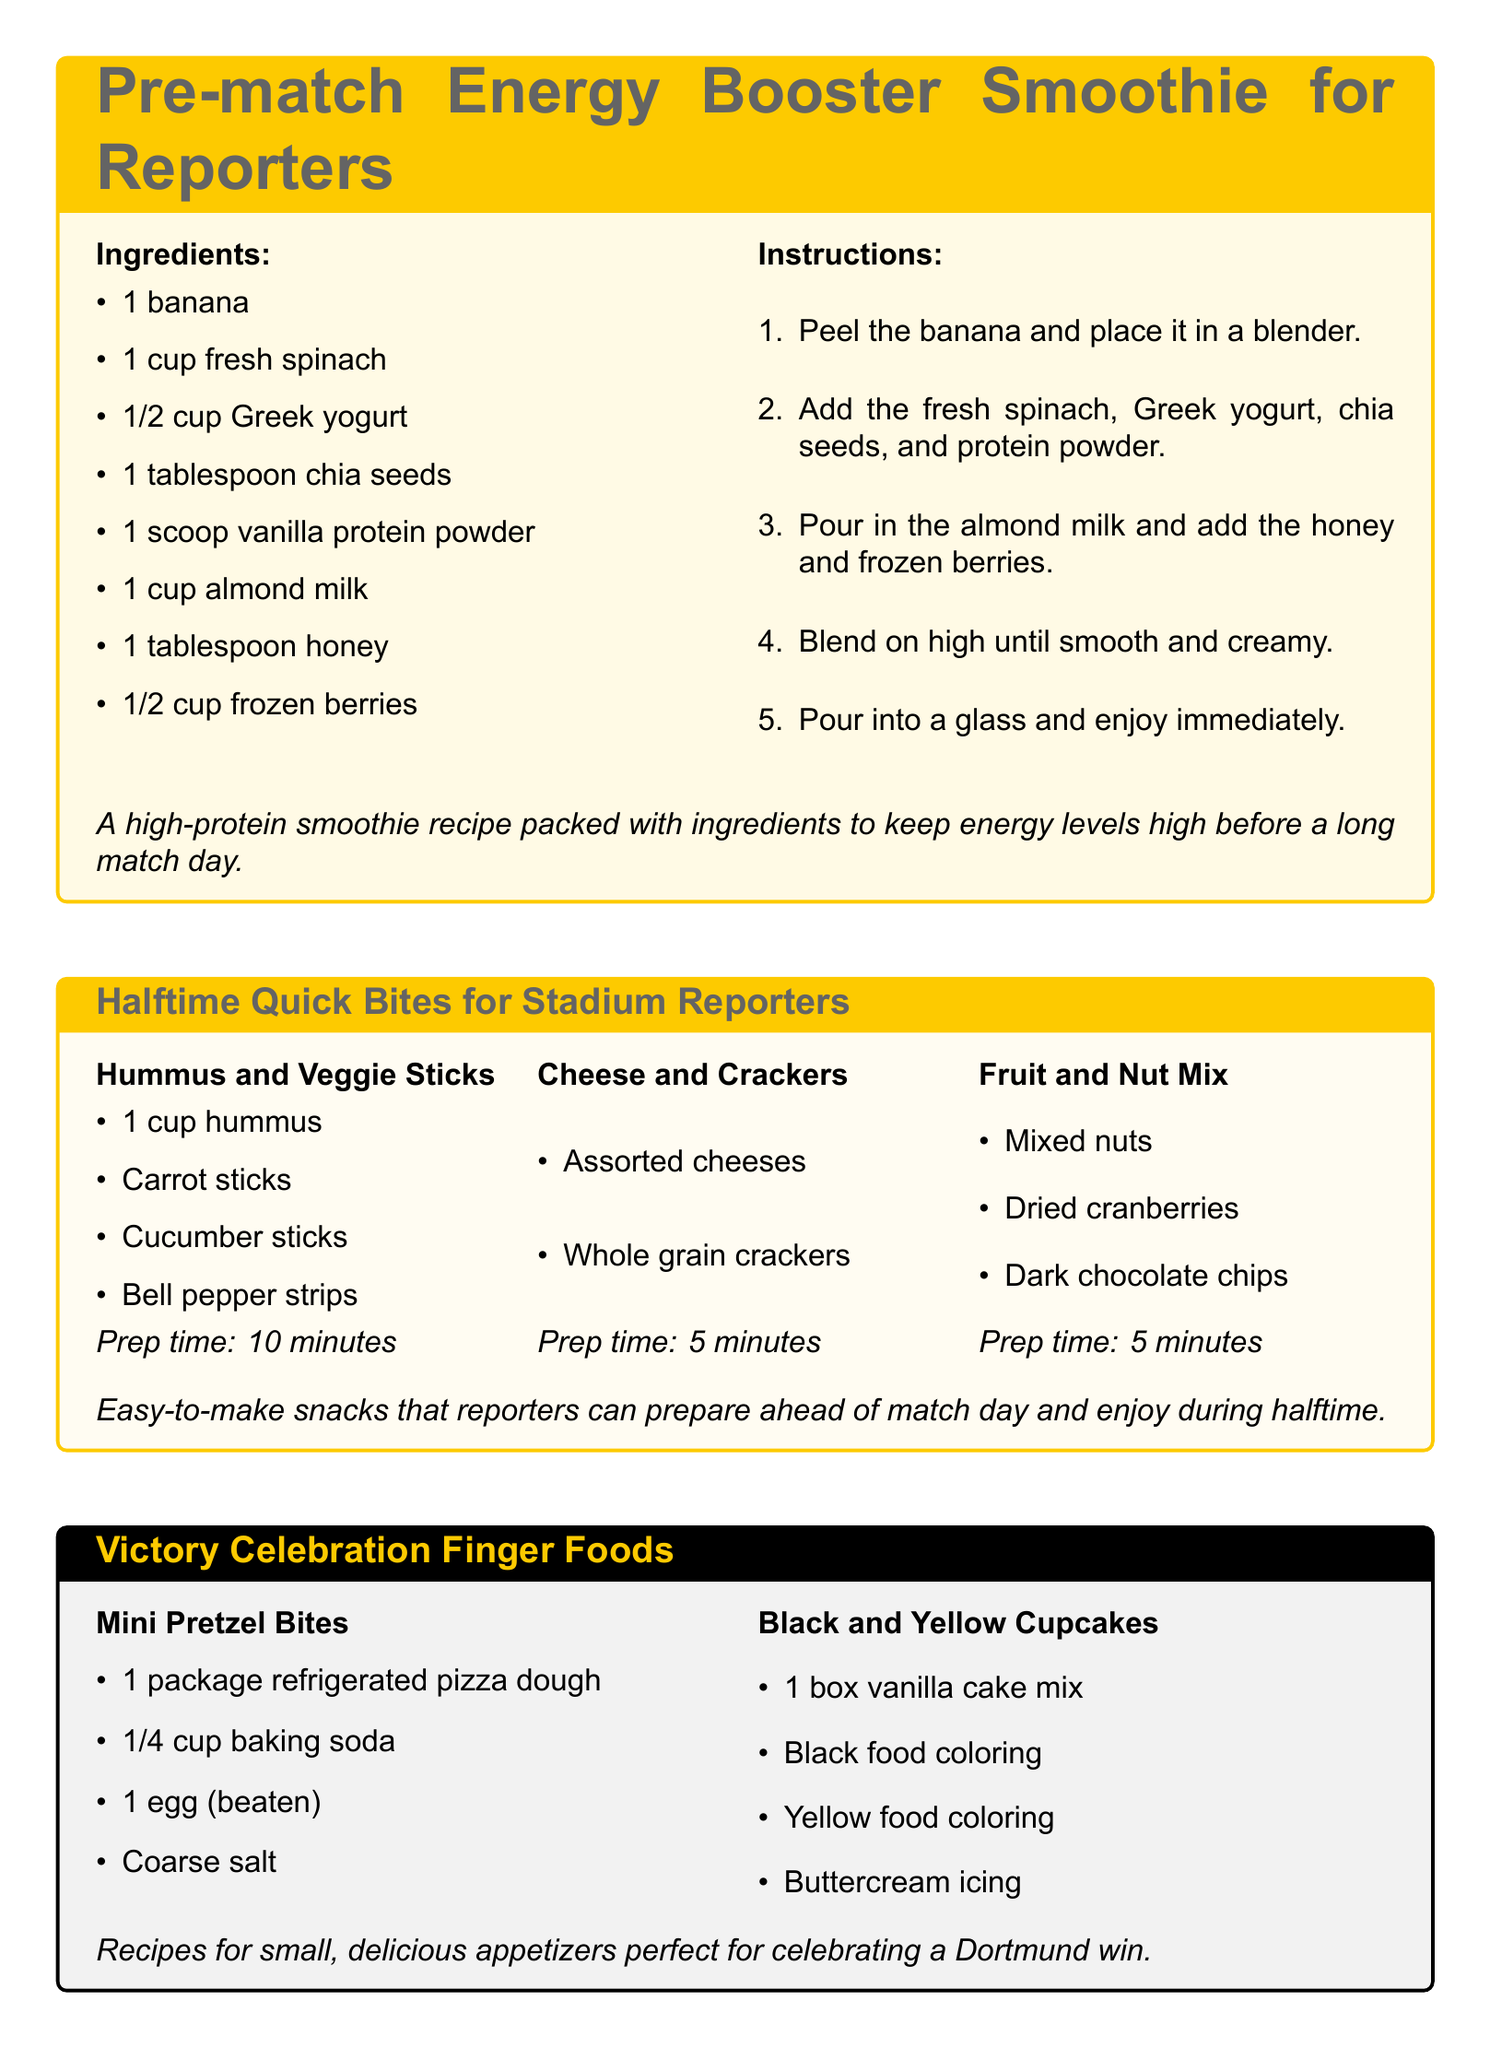What is the main color scheme of the Victory Celebration Finger Foods card? The main color scheme of the card showcases Dortmund's colors, black and yellow.
Answer: black and yellow How many ingredients are needed for the Pre-match Energy Booster Smoothie? The Pre-match Energy Booster Smoothie requires 8 ingredients.
Answer: 8 What is the preparation time for Cheese and Crackers? The preparation time for Cheese and Crackers is highlighted as 5 minutes in the document.
Answer: 5 minutes Which ingredient is used in both Black and Yellow Cupcakes and Mini Pretzel Bites? Both recipes utilize the ingredient of baking soda.
Answer: baking soda What type of meal does the Rainy Day Comfort Meals card focus on? The card emphasizes hearty, comforting meals ideal for cold match nights.
Answer: hearty, comforting meals 